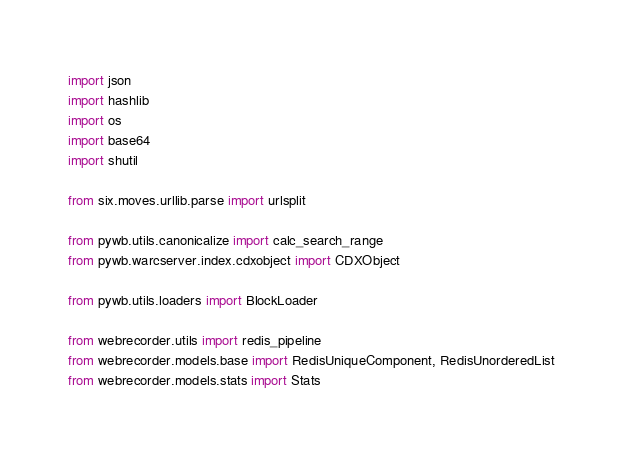Convert code to text. <code><loc_0><loc_0><loc_500><loc_500><_Python_>import json
import hashlib
import os
import base64
import shutil

from six.moves.urllib.parse import urlsplit

from pywb.utils.canonicalize import calc_search_range
from pywb.warcserver.index.cdxobject import CDXObject

from pywb.utils.loaders import BlockLoader

from webrecorder.utils import redis_pipeline
from webrecorder.models.base import RedisUniqueComponent, RedisUnorderedList
from webrecorder.models.stats import Stats</code> 